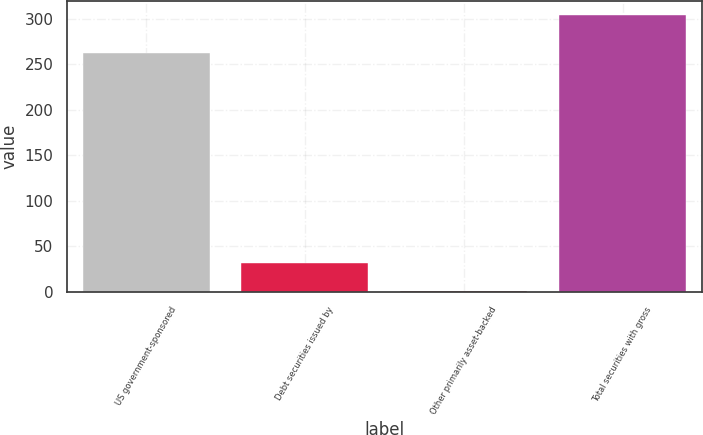<chart> <loc_0><loc_0><loc_500><loc_500><bar_chart><fcel>US government-sponsored<fcel>Debt securities issued by<fcel>Other primarily asset-backed<fcel>Total securities with gross<nl><fcel>262<fcel>31.3<fcel>1<fcel>304<nl></chart> 